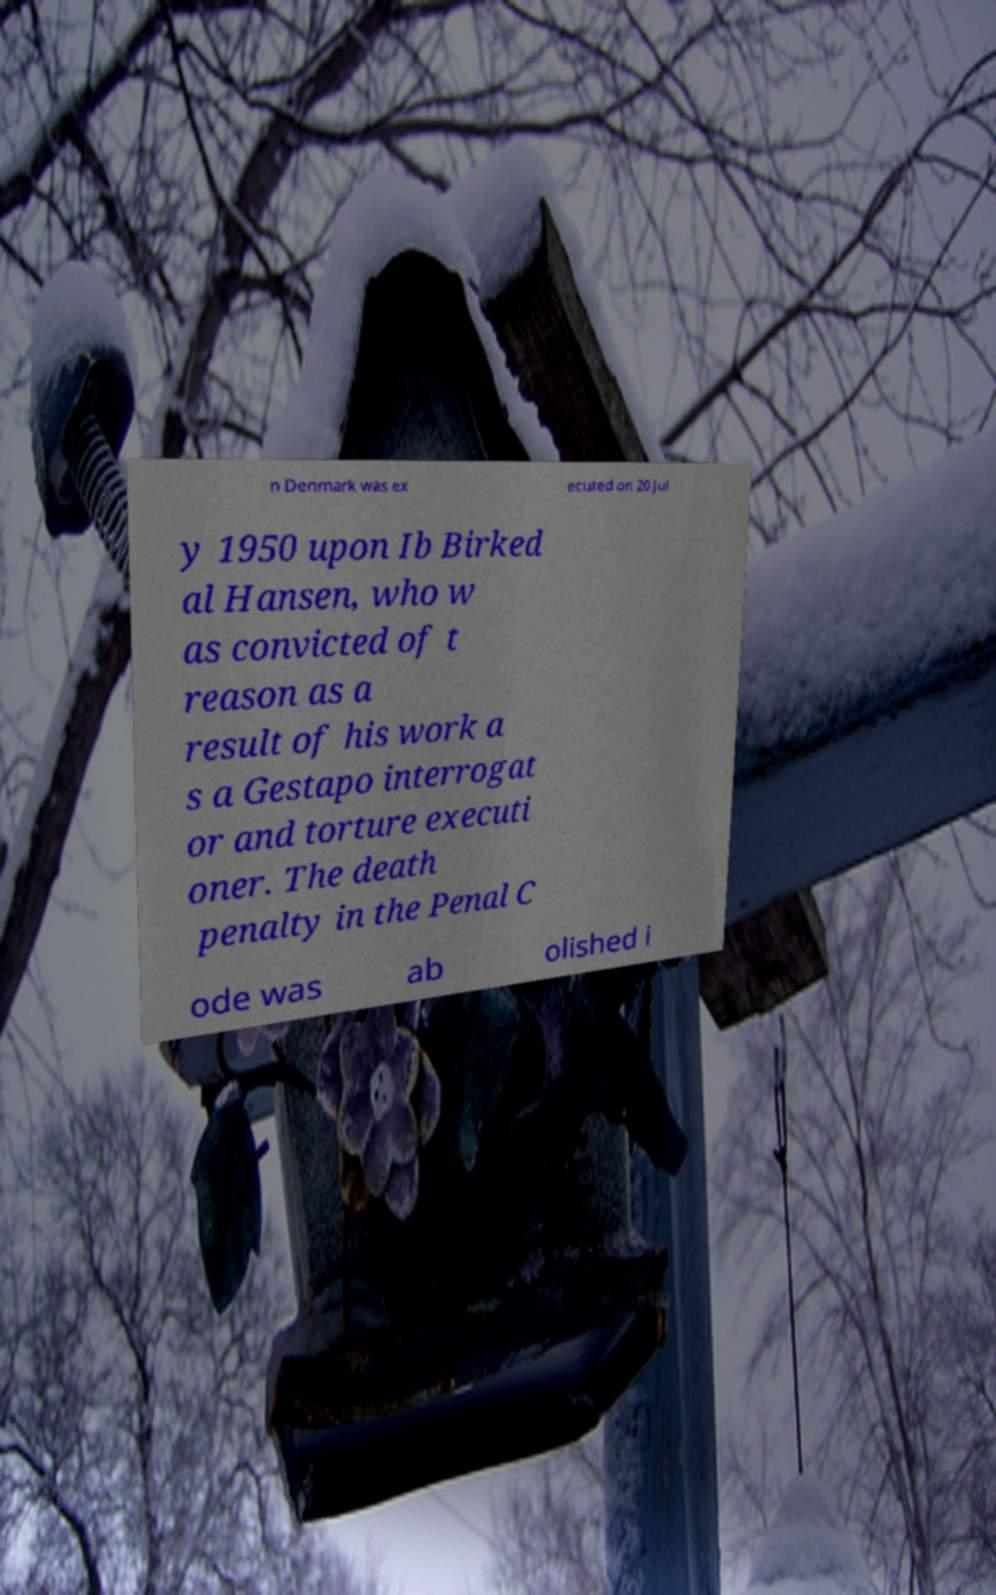Please read and relay the text visible in this image. What does it say? n Denmark was ex ecuted on 20 Jul y 1950 upon Ib Birked al Hansen, who w as convicted of t reason as a result of his work a s a Gestapo interrogat or and torture executi oner. The death penalty in the Penal C ode was ab olished i 